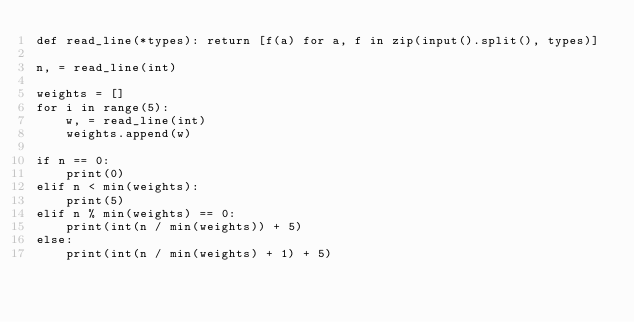Convert code to text. <code><loc_0><loc_0><loc_500><loc_500><_Python_>def read_line(*types): return [f(a) for a, f in zip(input().split(), types)]

n, = read_line(int)

weights = []
for i in range(5):
    w, = read_line(int)
    weights.append(w)

if n == 0:
    print(0)
elif n < min(weights):
    print(5)
elif n % min(weights) == 0:
    print(int(n / min(weights)) + 5)
else:
    print(int(n / min(weights) + 1) + 5)
    
</code> 